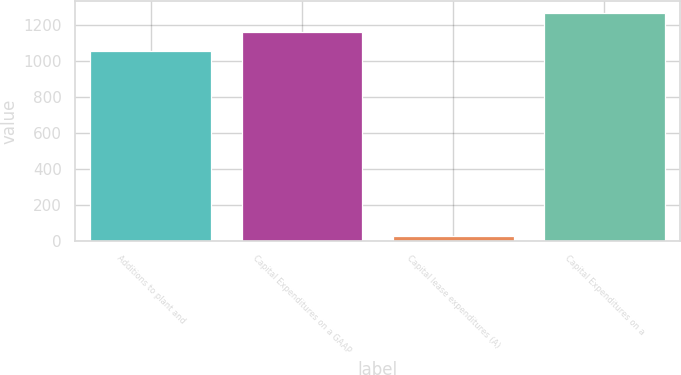Convert chart. <chart><loc_0><loc_0><loc_500><loc_500><bar_chart><fcel>Additions to plant and<fcel>Capital Expenditures on a GAAP<fcel>Capital lease expenditures (A)<fcel>Capital Expenditures on a<nl><fcel>1055.8<fcel>1161.38<fcel>27.2<fcel>1266.96<nl></chart> 